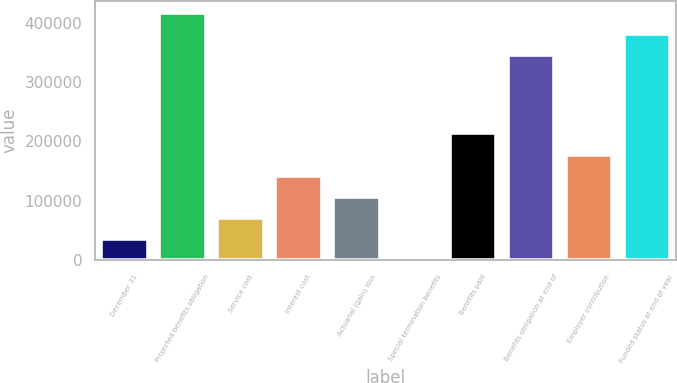Convert chart. <chart><loc_0><loc_0><loc_500><loc_500><bar_chart><fcel>December 31<fcel>Projected benefits obligation<fcel>Service cost<fcel>Interest cost<fcel>Actuarial (gain) loss<fcel>Special termination benefits<fcel>Benefits paid<fcel>Benefits obligation at end of<fcel>Employer contribution<fcel>Funded status at end of year<nl><fcel>35632.8<fcel>416282<fcel>71215.6<fcel>142381<fcel>106798<fcel>50<fcel>213547<fcel>345116<fcel>177964<fcel>380699<nl></chart> 